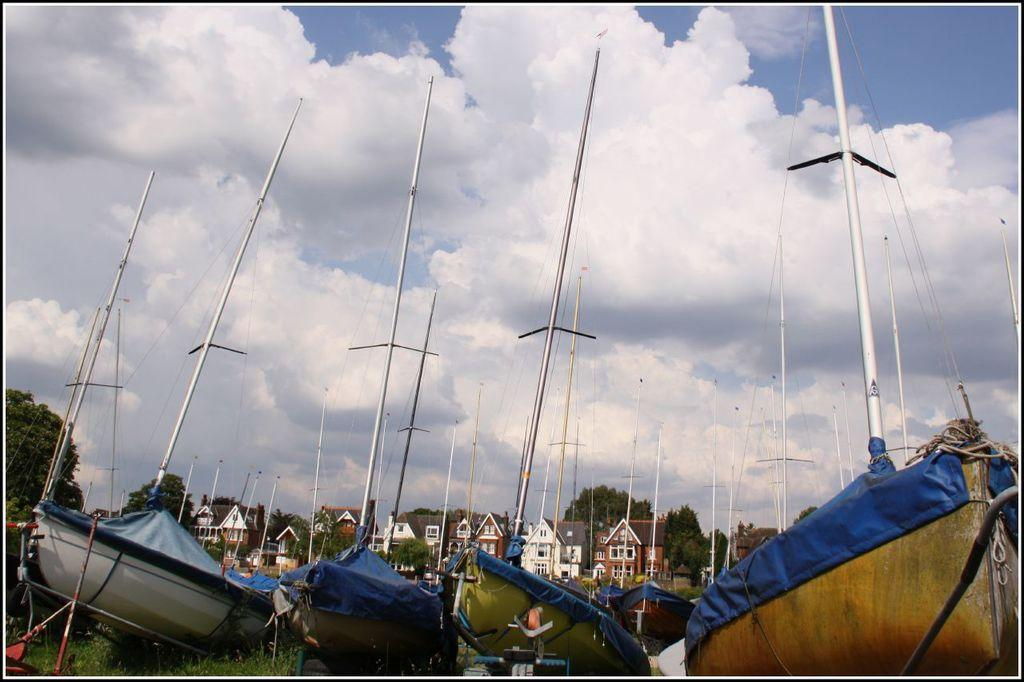What type of vehicles are present in the image? There are boats in the image. What feature can be seen on the boats? The boats have masts. What can be seen in the distance in the image? There are houses and trees in the background of the image. Where is the woman sitting in the image? There is no woman present in the image; it features boats with masts and a background of houses and trees. 